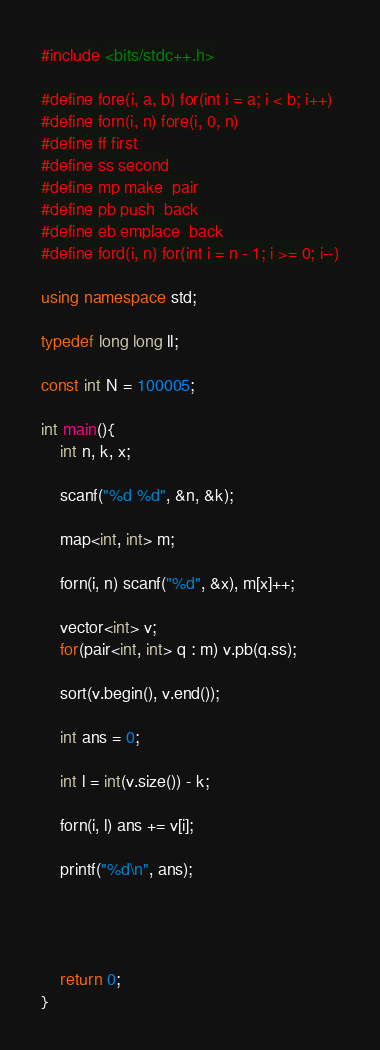Convert code to text. <code><loc_0><loc_0><loc_500><loc_500><_C++_>#include <bits/stdc++.h>

#define fore(i, a, b) for(int i = a; i < b; i++)
#define forn(i, n) fore(i, 0, n)
#define ff first
#define ss second
#define mp make_pair
#define pb push_back
#define eb emplace_back
#define ford(i, n) for(int i = n - 1; i >= 0; i--)

using namespace std;

typedef long long ll;

const int N = 100005;

int main(){
	int n, k, x;

	scanf("%d %d", &n, &k);

	map<int, int> m;

	forn(i, n) scanf("%d", &x), m[x]++;

	vector<int> v;
	for(pair<int, int> q : m) v.pb(q.ss);

	sort(v.begin(), v.end());

	int ans = 0;

	int l = int(v.size()) - k;

	forn(i, l) ans += v[i];

	printf("%d\n", ans);




    return 0;
}
</code> 